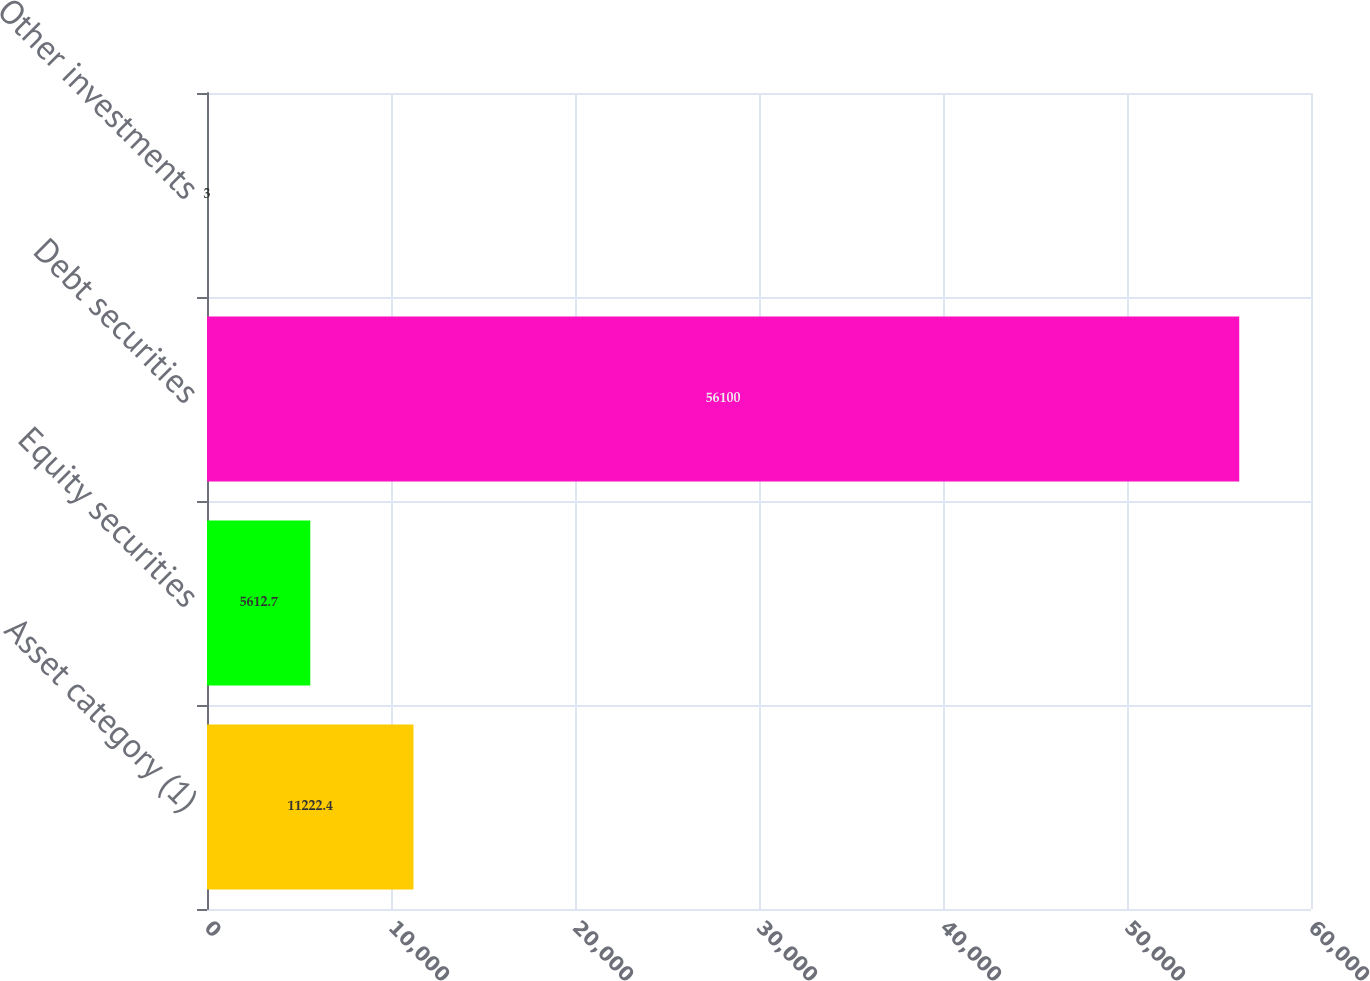Convert chart to OTSL. <chart><loc_0><loc_0><loc_500><loc_500><bar_chart><fcel>Asset category (1)<fcel>Equity securities<fcel>Debt securities<fcel>Other investments<nl><fcel>11222.4<fcel>5612.7<fcel>56100<fcel>3<nl></chart> 